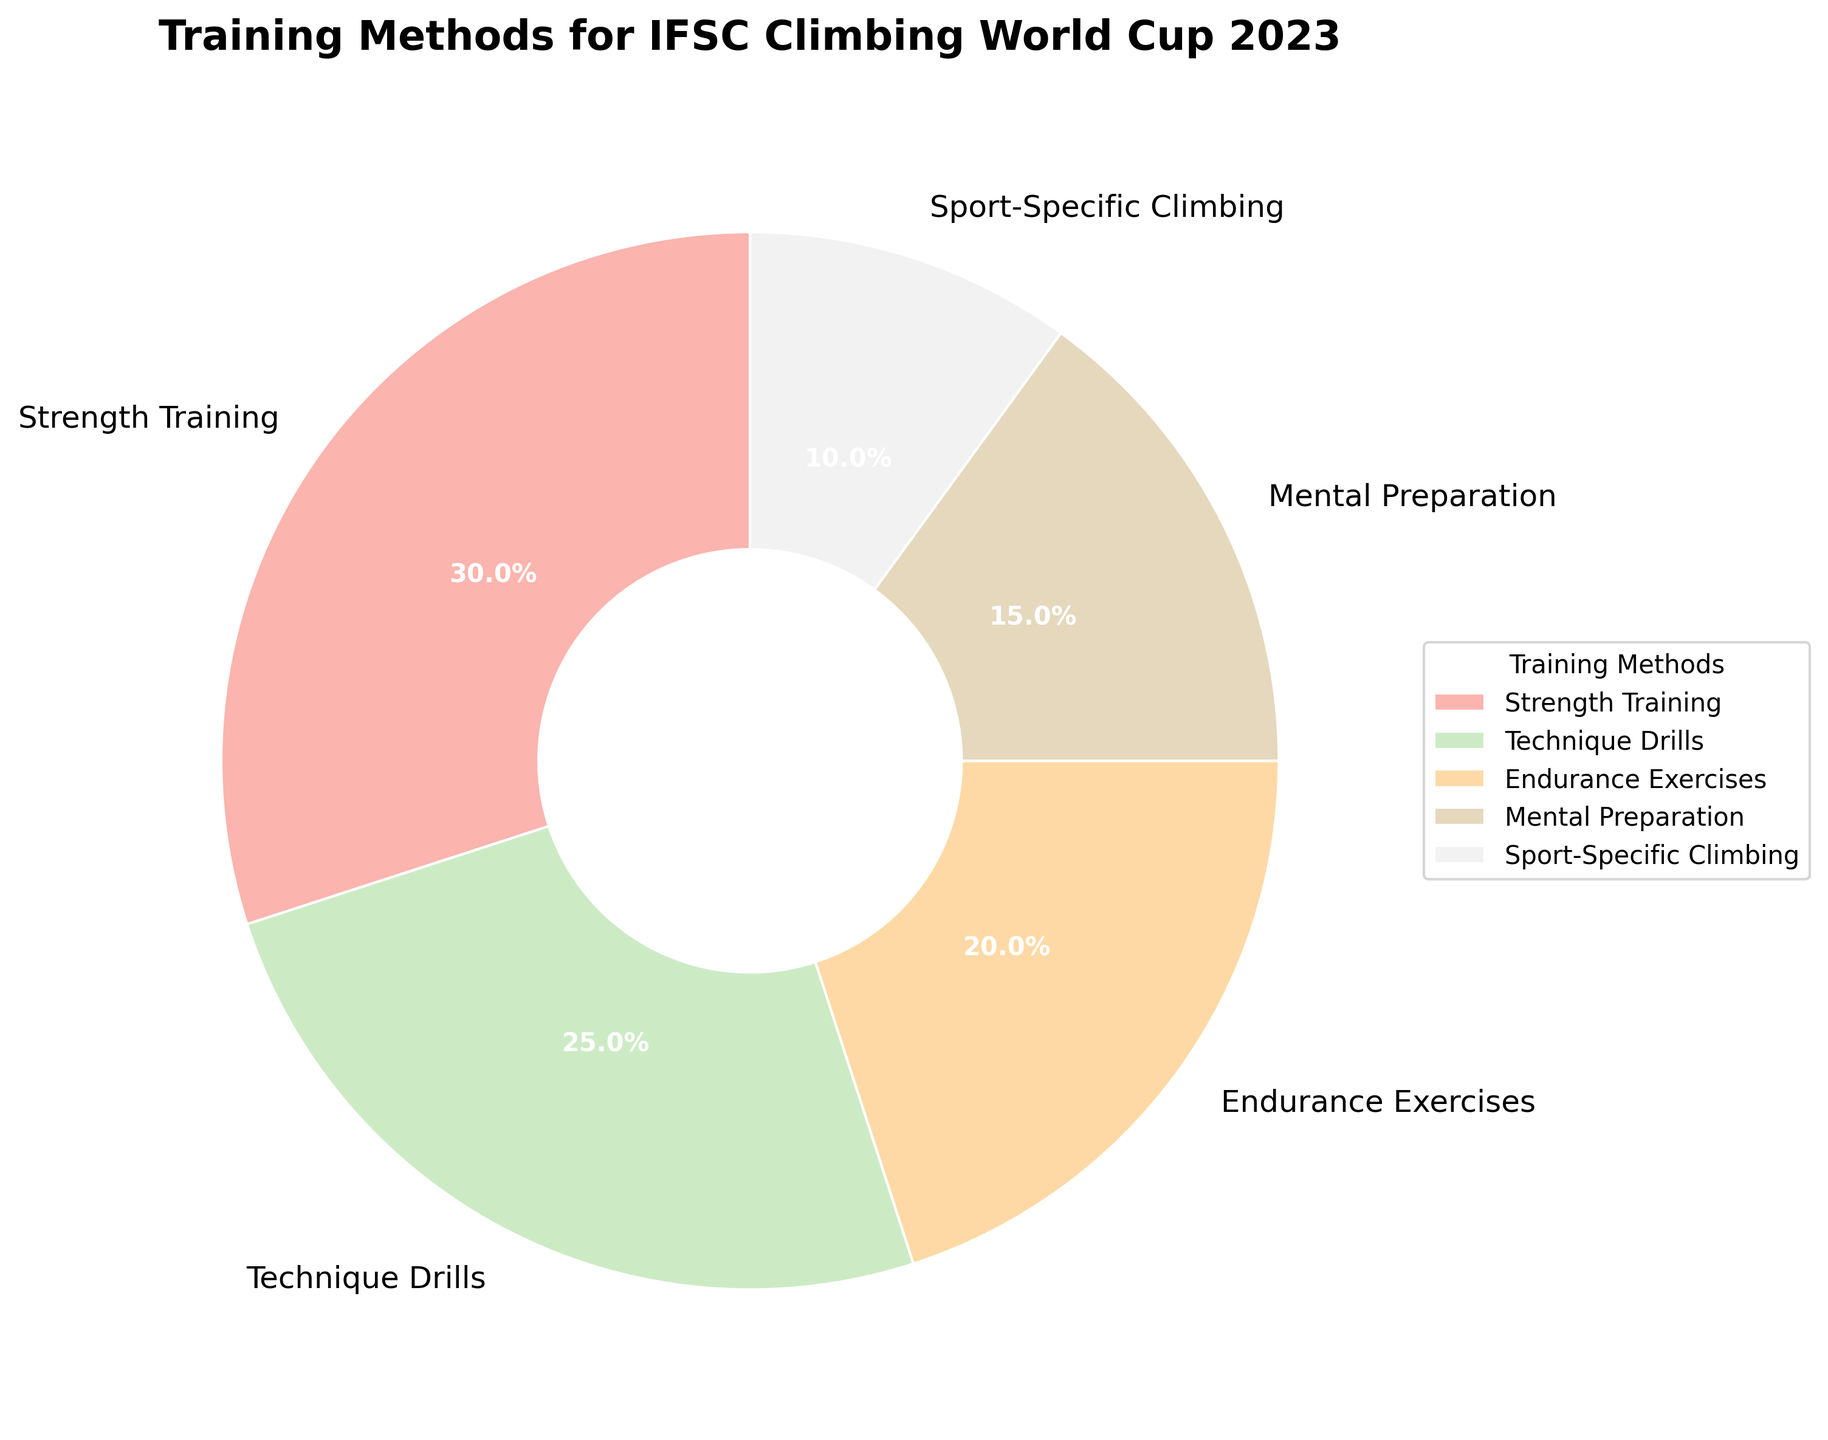Which training method is most commonly used among professional climbers? By observing the pie chart segments and their percentages, Strength Training has the largest segment which represents 30% of the total training methods used.
Answer: Strength Training Which method is represented by the smallest segment of the pie chart? By looking at the pie chart, Sport-Specific Climbing has the smallest segment, representing 10% of the training methods.
Answer: Sport-Specific Climbing What is the total percentage of climbers focusing on Technique Drills and Endurance Exercises? Adding the percentages of Technique Drills (25%) and Endurance Exercises (20%) gives 25% + 20% = 45%.
Answer: 45% Is the percentage of climbers focusing on Strength Training greater than the percentage focusing on Endurance Exercises? The percentage for Strength Training is 30%, and for Endurance Exercises, it's 20%. Comparing 30% > 20% confirms the statement.
Answer: Yes How much more percentage of climbers focus on Mental Preparation compared to Sport-Specific Climbing? Subtracting the percentage of Sport-Specific Climbing (10%) from Mental Preparation (15%) yields 15% - 10% = 5%.
Answer: 5% What is the proportion of climbers that focus on non-physical training methods (Mental Preparation) out of the total? The percentage of Mental Preparation is 15%. This is a straightforward read from the chart.
Answer: 15% What is the combined percentage of climbers focusing on either Mental Preparation or Sport-Specific Climbing? Adding the percentages for Mental Preparation (15%) and Sport-Specific Climbing (10%) results in 15% + 10% = 25%.
Answer: 25% Which training method has a relatively mid-range percentage compared to others? Technique Drills, with 25%, falls in the mid-range between the highest (30%) and the lowest (10%).
Answer: Technique Drills Compare the focus given to Strength Training and Technique Drills. Which one is higher and by what percentage? Strength Training is 30%, while Technique Drills is 25%. The difference is 30% - 25% = 5%.
Answer: Strength Training, 5% 